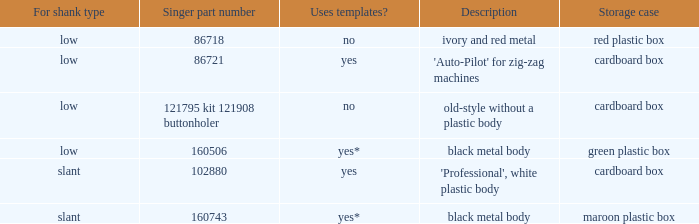What is the part number for the buttonholer with a green plastic storage case from singer? 160506.0. 